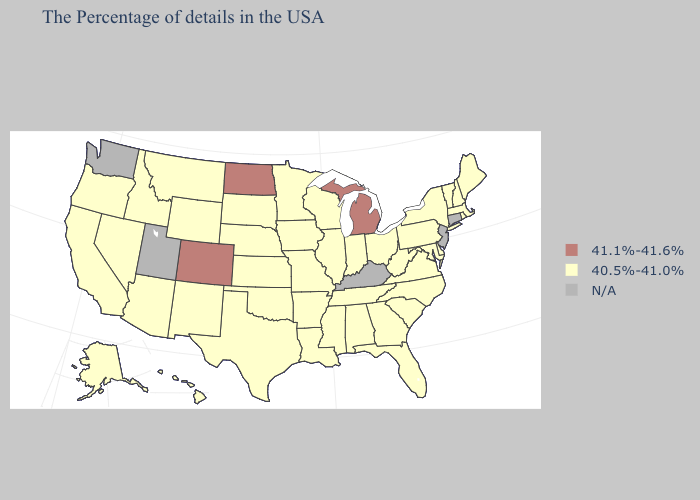Which states hav the highest value in the MidWest?
Concise answer only. Michigan, North Dakota. Does Colorado have the lowest value in the USA?
Keep it brief. No. Name the states that have a value in the range 41.1%-41.6%?
Give a very brief answer. Michigan, North Dakota, Colorado. How many symbols are there in the legend?
Quick response, please. 3. What is the lowest value in the South?
Keep it brief. 40.5%-41.0%. Among the states that border Rhode Island , which have the lowest value?
Keep it brief. Massachusetts. Does Colorado have the highest value in the West?
Quick response, please. Yes. What is the value of Idaho?
Concise answer only. 40.5%-41.0%. Does the map have missing data?
Answer briefly. Yes. Is the legend a continuous bar?
Write a very short answer. No. Among the states that border New Mexico , which have the highest value?
Write a very short answer. Colorado. What is the value of Pennsylvania?
Write a very short answer. 40.5%-41.0%. What is the value of Nevada?
Quick response, please. 40.5%-41.0%. Name the states that have a value in the range 40.5%-41.0%?
Quick response, please. Maine, Massachusetts, Rhode Island, New Hampshire, Vermont, New York, Delaware, Maryland, Pennsylvania, Virginia, North Carolina, South Carolina, West Virginia, Ohio, Florida, Georgia, Indiana, Alabama, Tennessee, Wisconsin, Illinois, Mississippi, Louisiana, Missouri, Arkansas, Minnesota, Iowa, Kansas, Nebraska, Oklahoma, Texas, South Dakota, Wyoming, New Mexico, Montana, Arizona, Idaho, Nevada, California, Oregon, Alaska, Hawaii. What is the lowest value in the USA?
Be succinct. 40.5%-41.0%. 